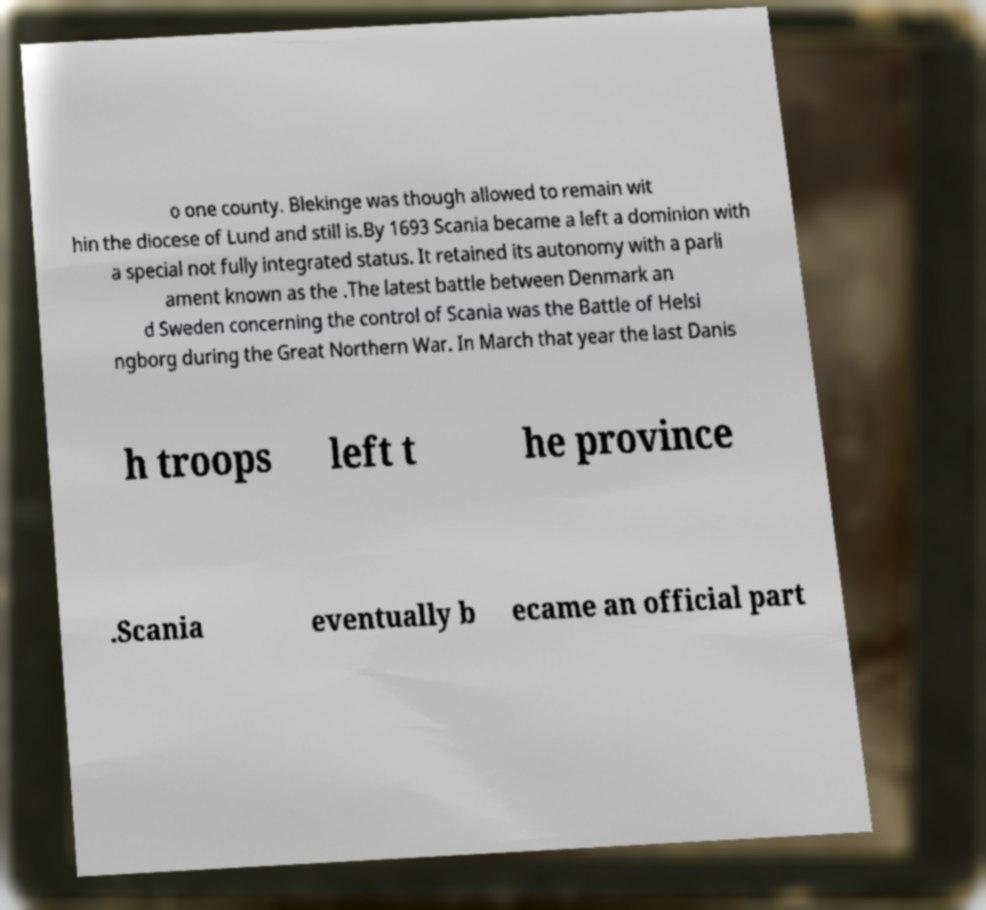Please read and relay the text visible in this image. What does it say? o one county. Blekinge was though allowed to remain wit hin the diocese of Lund and still is.By 1693 Scania became a left a dominion with a special not fully integrated status. It retained its autonomy with a parli ament known as the .The latest battle between Denmark an d Sweden concerning the control of Scania was the Battle of Helsi ngborg during the Great Northern War. In March that year the last Danis h troops left t he province .Scania eventually b ecame an official part 